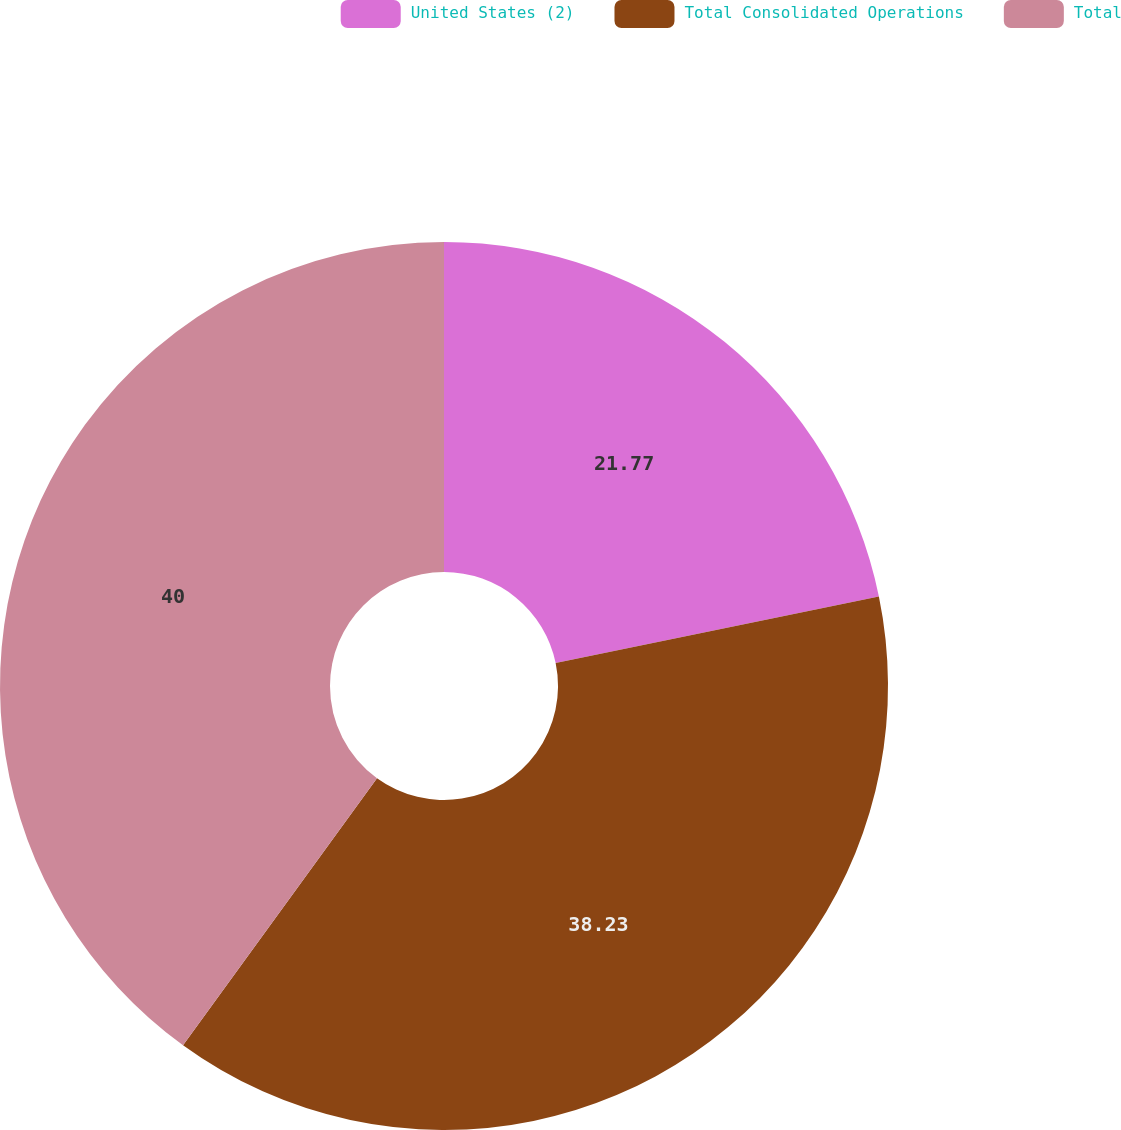Convert chart to OTSL. <chart><loc_0><loc_0><loc_500><loc_500><pie_chart><fcel>United States (2)<fcel>Total Consolidated Operations<fcel>Total<nl><fcel>21.77%<fcel>38.23%<fcel>40.0%<nl></chart> 